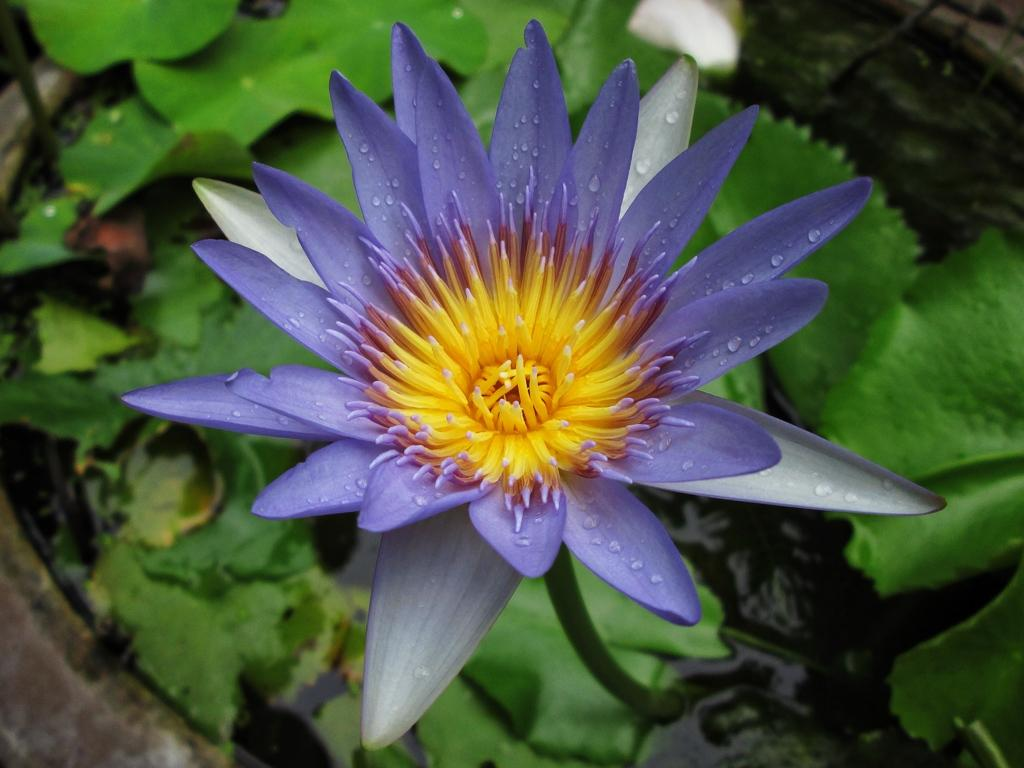What colors are present in the flower in the image? The flower in the image has violet and yellow colors. What other part of the flower can be seen besides the petals? The flower has green leaves. What can be seen in the background of the image? There is water visible in the background of the image. What type of bait is being used to catch fish in the image? There is no bait or fishing activity present in the image; it features a flower with green leaves and water in the background. What is the feeling of the flower in the image? The flower is an inanimate object and does not have feelings. 